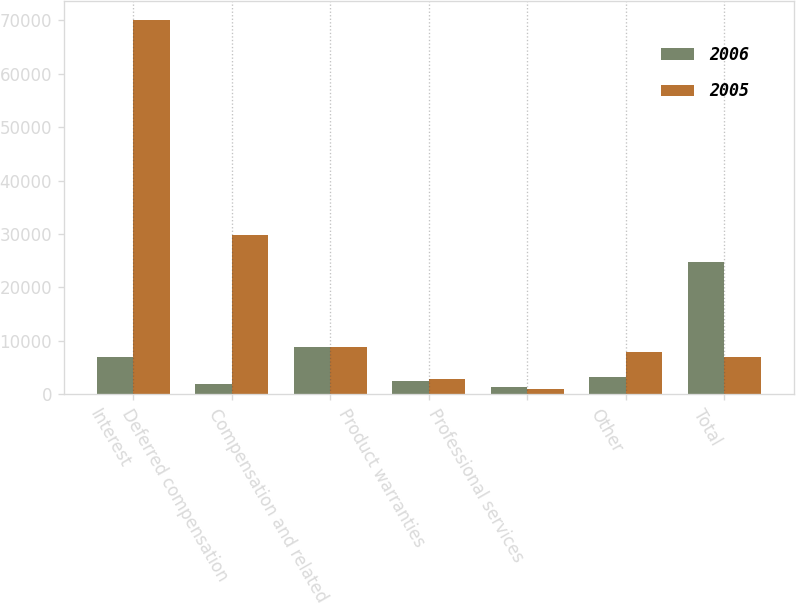<chart> <loc_0><loc_0><loc_500><loc_500><stacked_bar_chart><ecel><fcel>Interest<fcel>Deferred compensation<fcel>Compensation and related<fcel>Product warranties<fcel>Professional services<fcel>Other<fcel>Total<nl><fcel>2006<fcel>6913<fcel>1888<fcel>8831<fcel>2472<fcel>1373<fcel>3198<fcel>24675<nl><fcel>2005<fcel>70109<fcel>29736<fcel>8858<fcel>2789<fcel>940<fcel>7993<fcel>6913<nl></chart> 